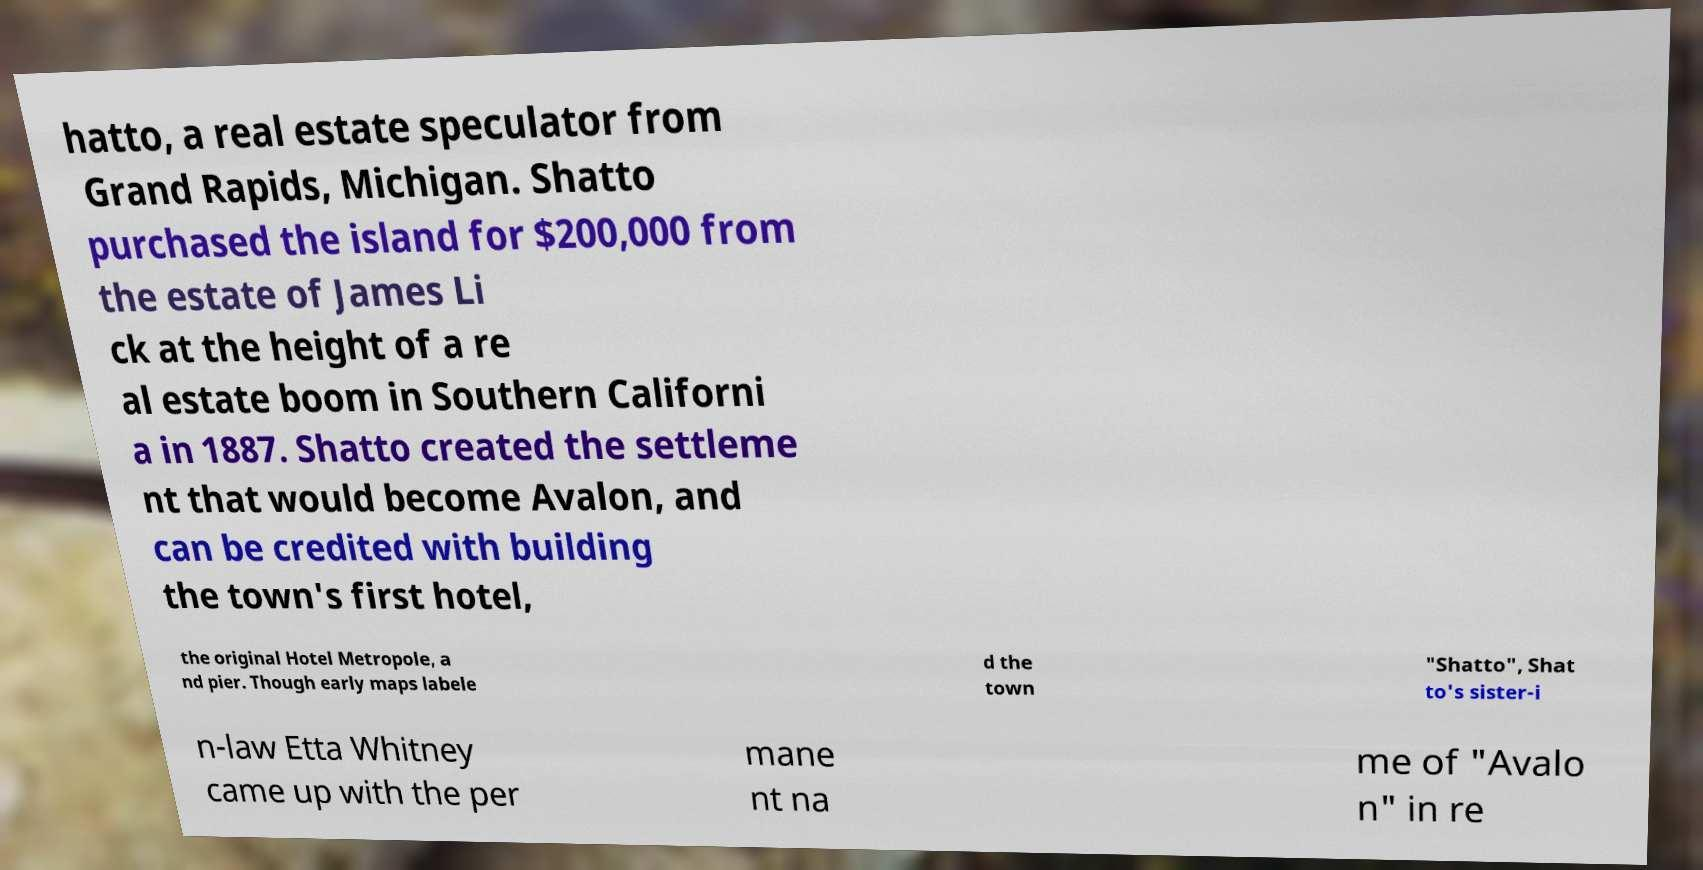What messages or text are displayed in this image? I need them in a readable, typed format. hatto, a real estate speculator from Grand Rapids, Michigan. Shatto purchased the island for $200,000 from the estate of James Li ck at the height of a re al estate boom in Southern Californi a in 1887. Shatto created the settleme nt that would become Avalon, and can be credited with building the town's first hotel, the original Hotel Metropole, a nd pier. Though early maps labele d the town "Shatto", Shat to's sister-i n-law Etta Whitney came up with the per mane nt na me of "Avalo n" in re 